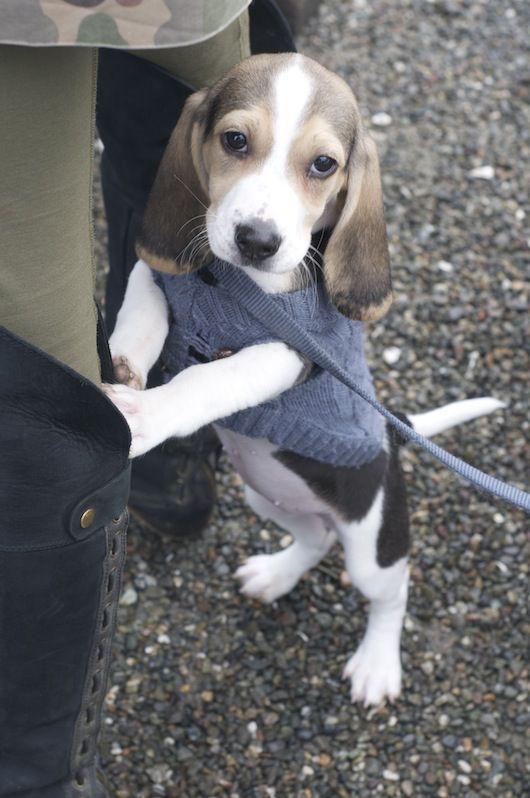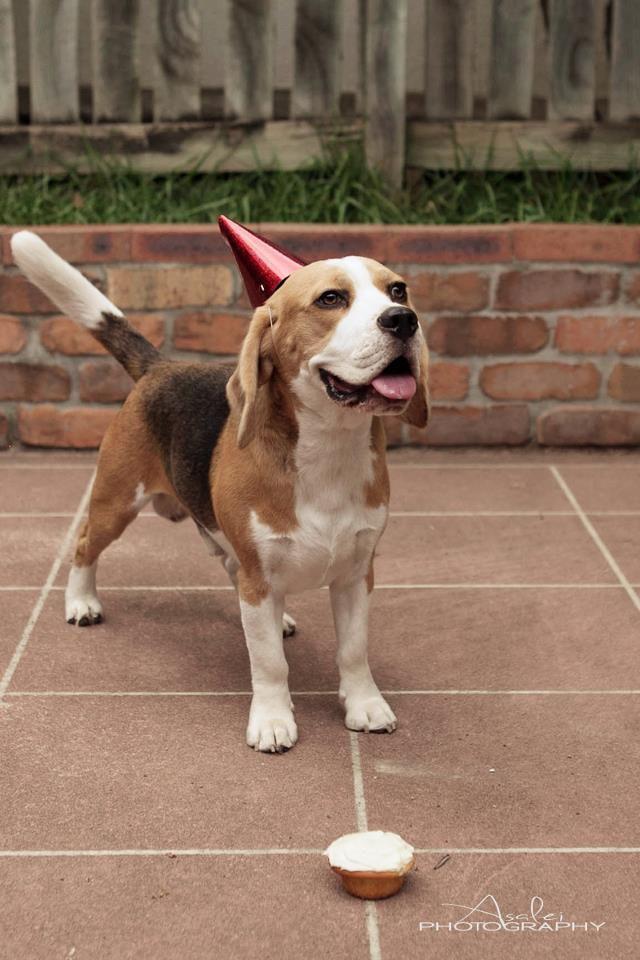The first image is the image on the left, the second image is the image on the right. Given the left and right images, does the statement "There are two dog figurines on the left." hold true? Answer yes or no. No. The first image is the image on the left, the second image is the image on the right. For the images displayed, is the sentence "There is only one real dog in total." factually correct? Answer yes or no. No. 